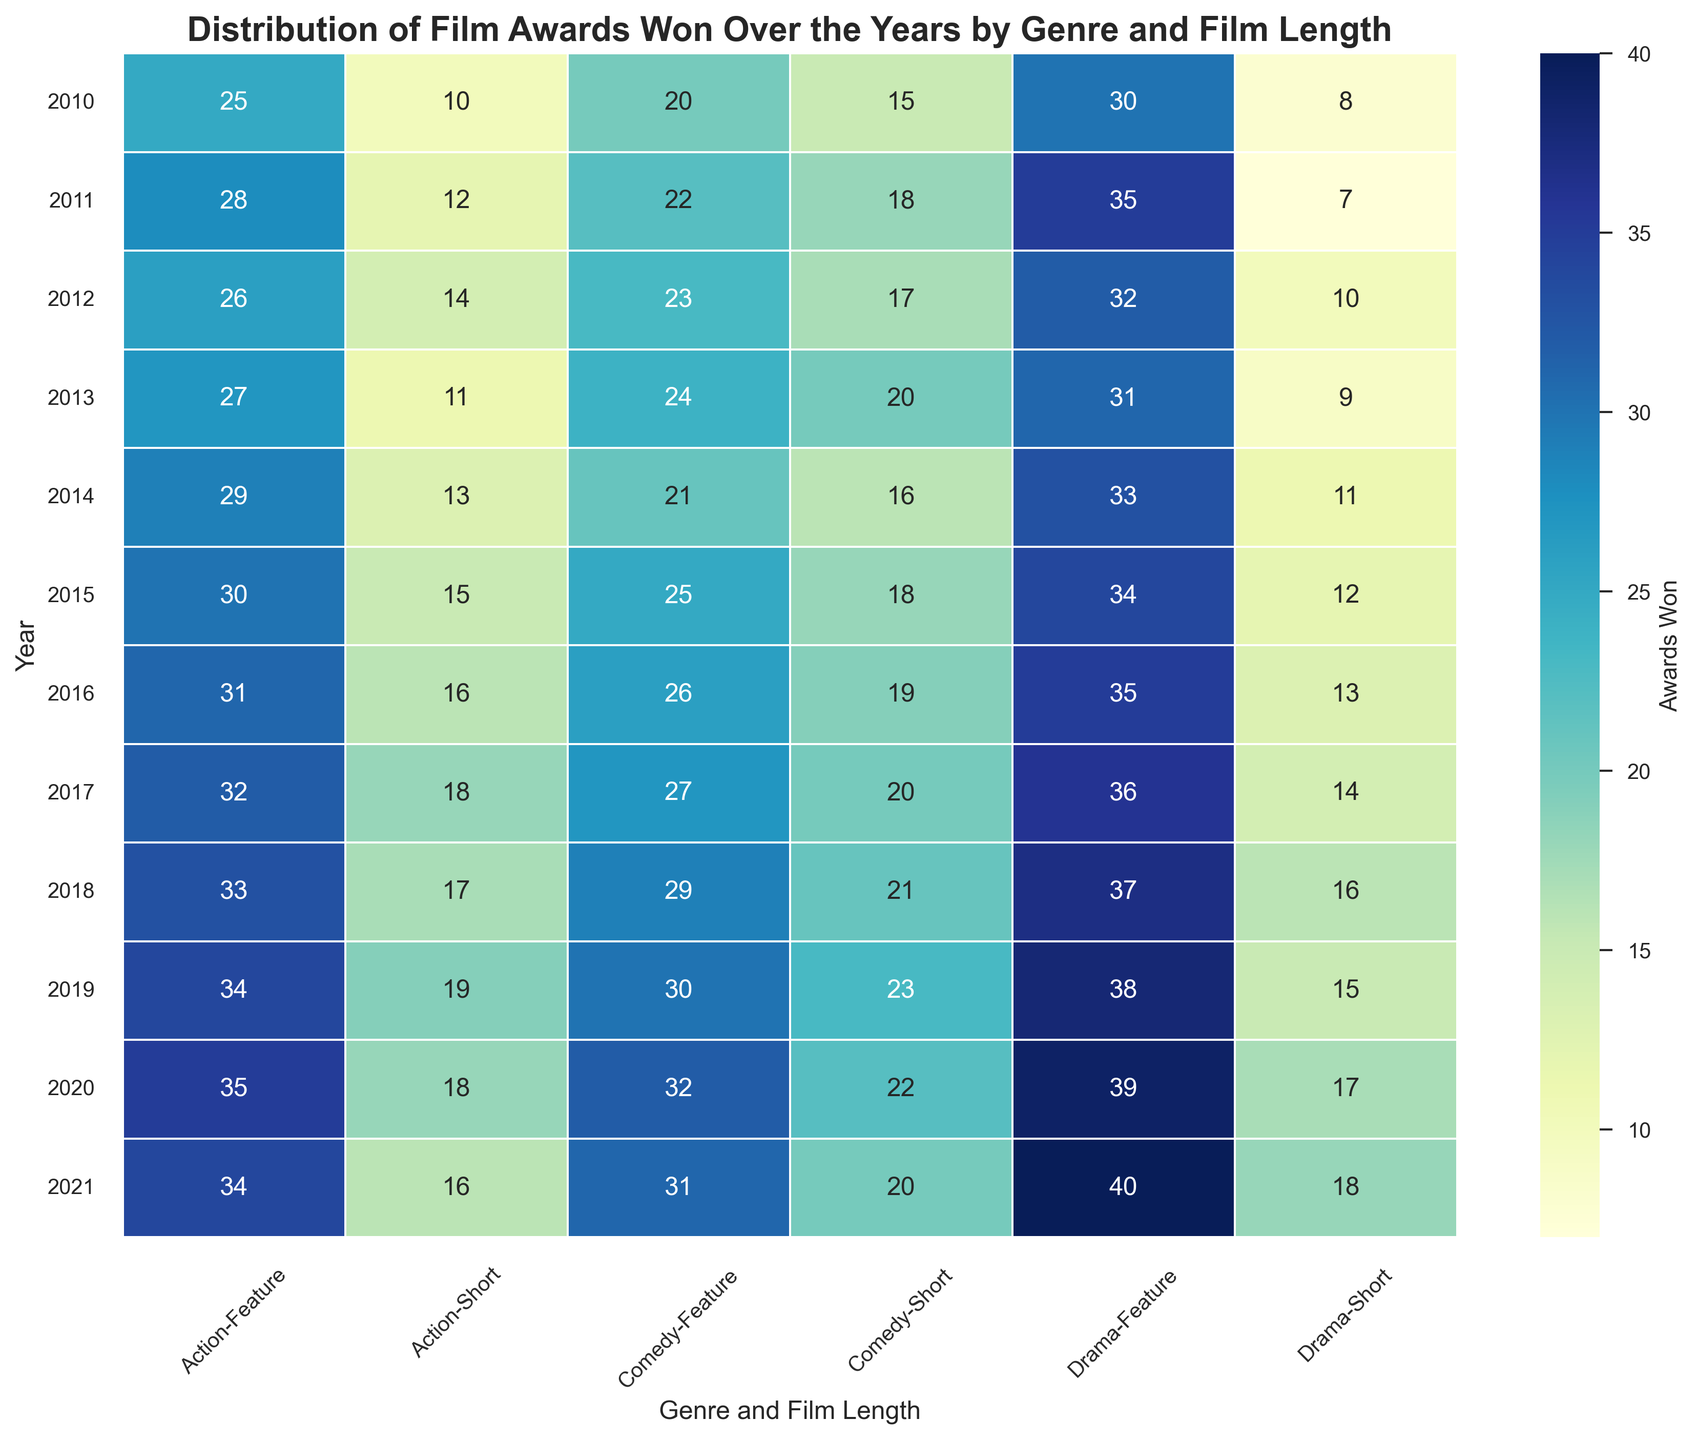What year did drama feature-length films win the most awards? Look for the cell with the highest value in the 'Drama Feature' column. The value 40 is in the year 2021.
Answer: 2021 Which genre has consistently won more awards in feature-length films than in short films over the years? Compare the values for each year between 'Feature' and 'Short' in Action, Comedy, and Drama genres. 'Drama Feature' consistently has higher values than 'Drama Short' each year.
Answer: Drama In which year did comedy short films win the highest number of awards? Search for the maximum value in the 'Comedy Short' column, which is 23. This value is in the year 2019.
Answer: 2019 How many awards did action short films win in 2017 compared to 2016? In the 'Action Short' column, the value for 2017 is 18. The value for 2016 is 16. Subtract 16 from 18 to find the difference. 18 - 16 = 2.
Answer: 2 What's the difference in awards won by comedy feature-length films between 2018 and 2020? Look at the 'Comedy Feature' column for the years 2018 and 2020. The values are 29 and 32, respectively. Subtract 29 from 32: 32 - 29 = 3.
Answer: 3 In which year did action feature-length films win their highest number of awards? Look for the maximum value in the 'Action Feature' column. It is 35 in the year 2020.
Answer: 2020 What is the average number of awards won by drama short films from 2010 to 2015? Sum the values for 'Drama Short' from 2010 to 2015: 8 + 7 + 10 + 9 + 11 + 12 = 57. Divide 57 by the number of years (6): 57 / 6 = 9.5.
Answer: 9.5 How does the total number of awards won by comedy short films in 2012 compare to drama short films in the same year? The 'Comedy Short' value for 2012 is 17, and the 'Drama Short' value for the same year is 10. 17 is greater than 10.
Answer: Comedy Short films won more Which genre and film length combination had the most awards won in 2019? Check the values for 2019 across all genre and film length combinations. 'Drama Feature' has the highest value at 38.
Answer: Drama Feature Is there an increasing or decreasing trend in the number of awards won by action feature-length films from 2010 to 2021? Examine the 'Action Feature' values from 2010 to 2021. The values show a general increasing trend: 25, 28, 26, 27, 29, 30, 31, 32, 33, 34, 35, 34.
Answer: Increasing 